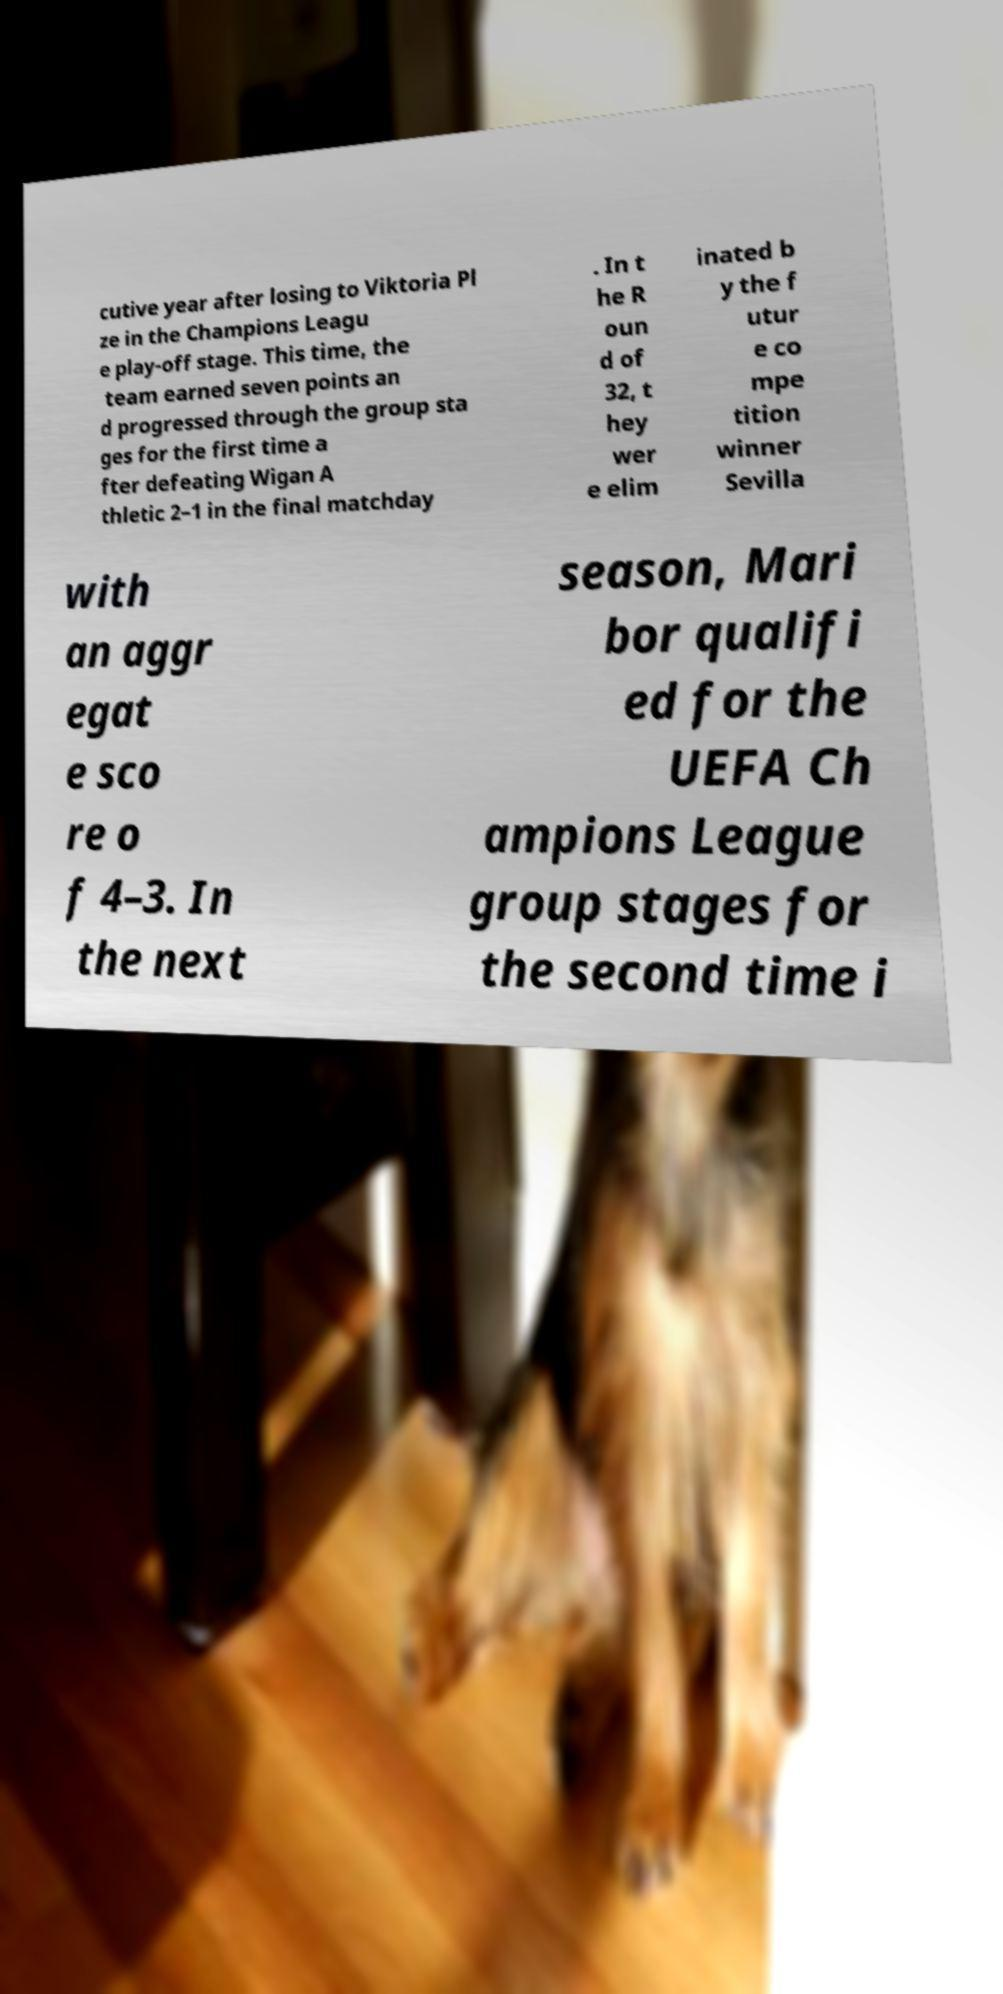What messages or text are displayed in this image? I need them in a readable, typed format. cutive year after losing to Viktoria Pl ze in the Champions Leagu e play-off stage. This time, the team earned seven points an d progressed through the group sta ges for the first time a fter defeating Wigan A thletic 2–1 in the final matchday . In t he R oun d of 32, t hey wer e elim inated b y the f utur e co mpe tition winner Sevilla with an aggr egat e sco re o f 4–3. In the next season, Mari bor qualifi ed for the UEFA Ch ampions League group stages for the second time i 